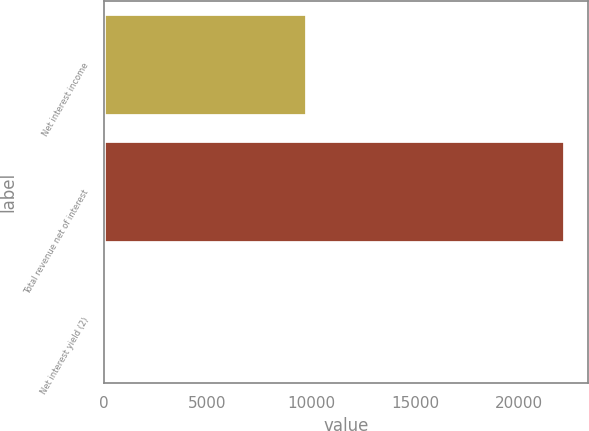Convert chart. <chart><loc_0><loc_0><loc_500><loc_500><bar_chart><fcel>Net interest income<fcel>Total revenue net of interest<fcel>Net interest yield (2)<nl><fcel>9782<fcel>22202<fcel>2.21<nl></chart> 